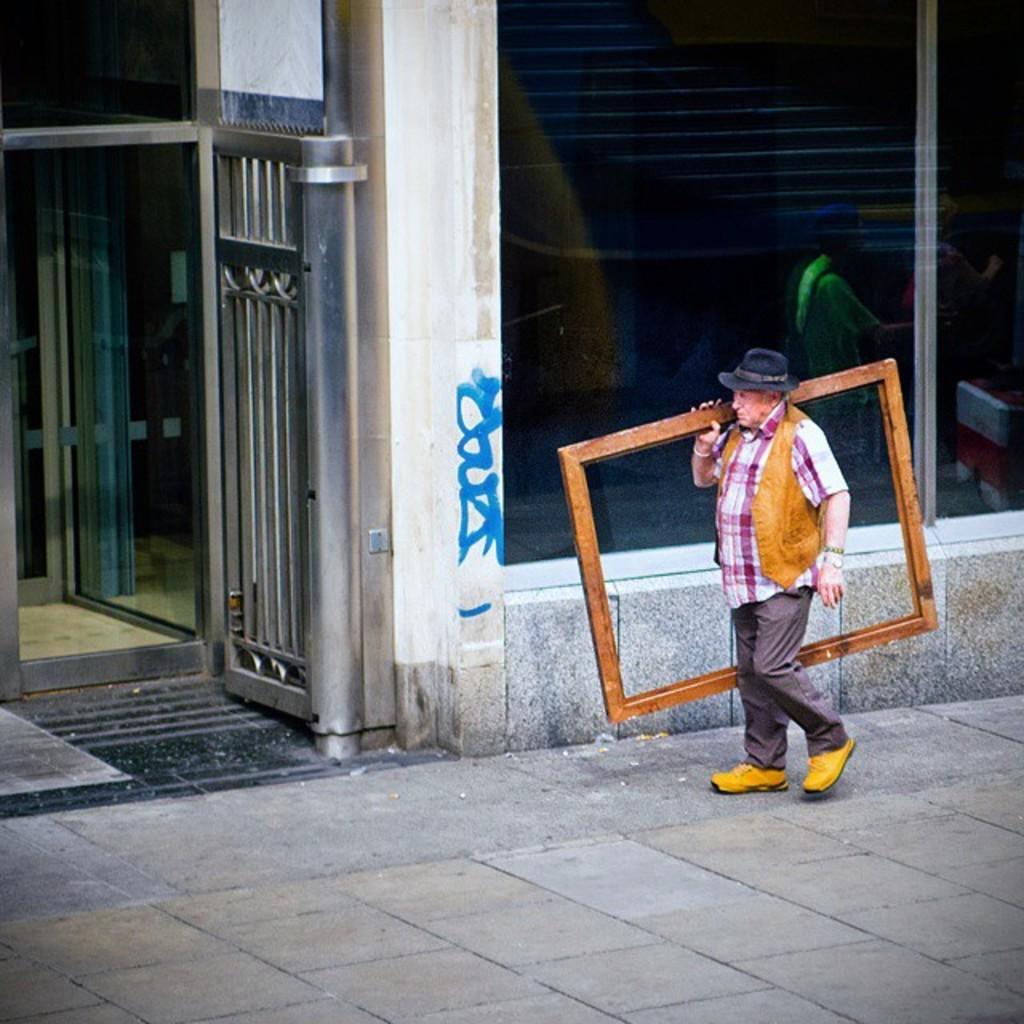In one or two sentences, can you explain what this image depicts? In this image there is a person walking on the road and he is holding a wooden structure, behind him there is a building, beside the building there is a gate. 